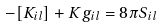<formula> <loc_0><loc_0><loc_500><loc_500>- [ { K } _ { i l } ] + { K } g _ { i l } = 8 \pi { S _ { i l } }</formula> 